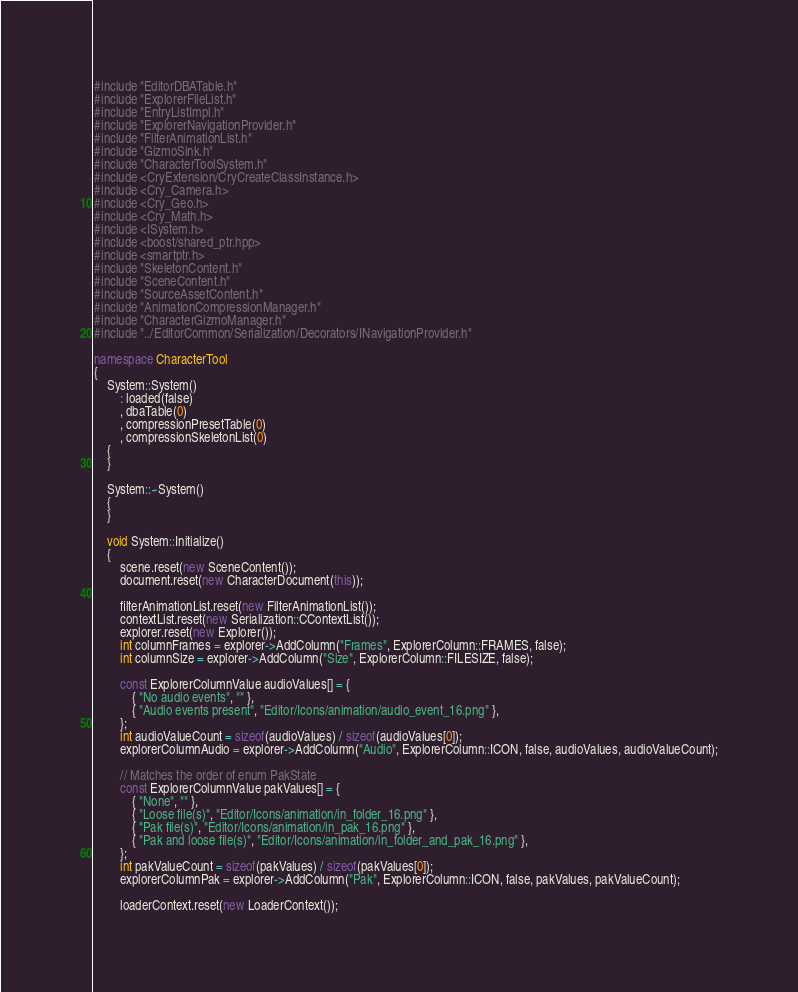Convert code to text. <code><loc_0><loc_0><loc_500><loc_500><_C++_>#include "EditorDBATable.h"
#include "ExplorerFileList.h"
#include "EntryListImpl.h"
#include "ExplorerNavigationProvider.h"
#include "FilterAnimationList.h"
#include "GizmoSink.h"
#include "CharacterToolSystem.h"
#include <CryExtension/CryCreateClassInstance.h>
#include <Cry_Camera.h>
#include <Cry_Geo.h>
#include <Cry_Math.h>
#include <ISystem.h>
#include <boost/shared_ptr.hpp>
#include <smartptr.h>
#include "SkeletonContent.h"
#include "SceneContent.h"
#include "SourceAssetContent.h"
#include "AnimationCompressionManager.h"
#include "CharacterGizmoManager.h"
#include "../EditorCommon/Serialization/Decorators/INavigationProvider.h"

namespace CharacterTool
{
    System::System()
        : loaded(false)
        , dbaTable(0)
        , compressionPresetTable(0)
        , compressionSkeletonList(0)
    {
    }

    System::~System()
    {
    }

    void System::Initialize()
    {
        scene.reset(new SceneContent());
        document.reset(new CharacterDocument(this));

        filterAnimationList.reset(new FilterAnimationList());
        contextList.reset(new Serialization::CContextList());
        explorer.reset(new Explorer());
        int columnFrames = explorer->AddColumn("Frames", ExplorerColumn::FRAMES, false);
        int columnSize = explorer->AddColumn("Size", ExplorerColumn::FILESIZE, false);

        const ExplorerColumnValue audioValues[] = {
            { "No audio events", "" },
            { "Audio events present", "Editor/Icons/animation/audio_event_16.png" },
        };
        int audioValueCount = sizeof(audioValues) / sizeof(audioValues[0]);
        explorerColumnAudio = explorer->AddColumn("Audio", ExplorerColumn::ICON, false, audioValues, audioValueCount);

        // Matches the order of enum PakState
        const ExplorerColumnValue pakValues[] = {
            { "None", "" },
            { "Loose file(s)", "Editor/Icons/animation/in_folder_16.png" },
            { "Pak file(s)", "Editor/Icons/animation/in_pak_16.png" },
            { "Pak and loose file(s)", "Editor/Icons/animation/in_folder_and_pak_16.png" },
        };
        int pakValueCount = sizeof(pakValues) / sizeof(pakValues[0]);
        explorerColumnPak = explorer->AddColumn("Pak", ExplorerColumn::ICON, false, pakValues, pakValueCount);

        loaderContext.reset(new LoaderContext());</code> 